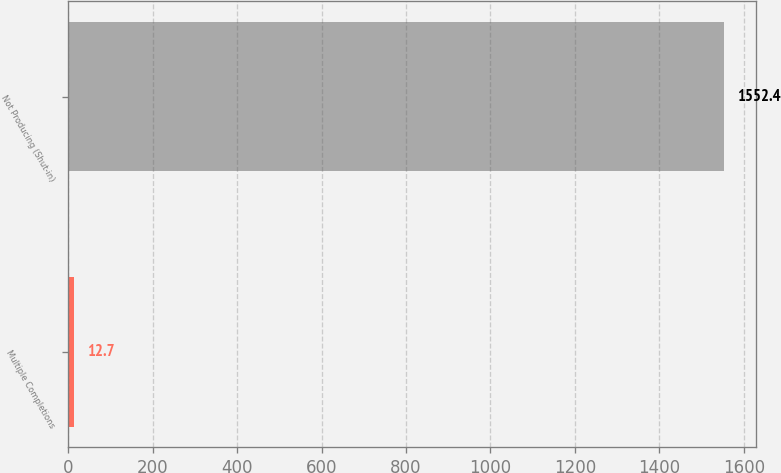<chart> <loc_0><loc_0><loc_500><loc_500><bar_chart><fcel>Multiple Completions<fcel>Not Producing (Shut-in)<nl><fcel>12.7<fcel>1552.4<nl></chart> 